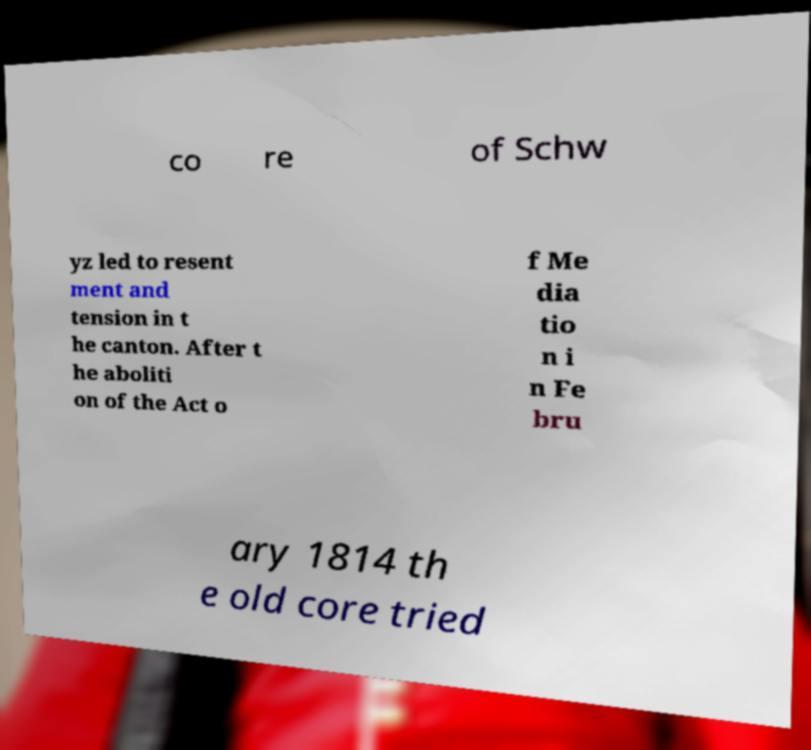Could you assist in decoding the text presented in this image and type it out clearly? co re of Schw yz led to resent ment and tension in t he canton. After t he aboliti on of the Act o f Me dia tio n i n Fe bru ary 1814 th e old core tried 